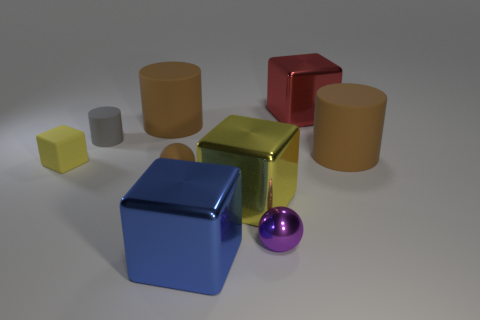What material is the thing that is the same color as the matte block?
Provide a short and direct response. Metal. There is a tiny rubber sphere; is its color the same as the large matte cylinder left of the small brown rubber object?
Your answer should be compact. Yes. How many other objects are there of the same color as the tiny cube?
Keep it short and to the point. 1. Is there a matte cylinder left of the large brown matte cylinder in front of the tiny gray object?
Your answer should be compact. Yes. The red cube has what size?
Your answer should be compact. Large. What is the shape of the small matte thing that is on the right side of the tiny yellow matte block and in front of the tiny rubber cylinder?
Ensure brevity in your answer.  Sphere. How many brown things are spheres or tiny rubber things?
Offer a very short reply. 1. Does the yellow object that is to the right of the tiny brown object have the same size as the object that is in front of the small purple thing?
Provide a succinct answer. Yes. How many objects are either large shiny balls or brown matte things?
Your response must be concise. 3. Is there a small rubber object of the same shape as the small purple metallic object?
Provide a succinct answer. Yes. 